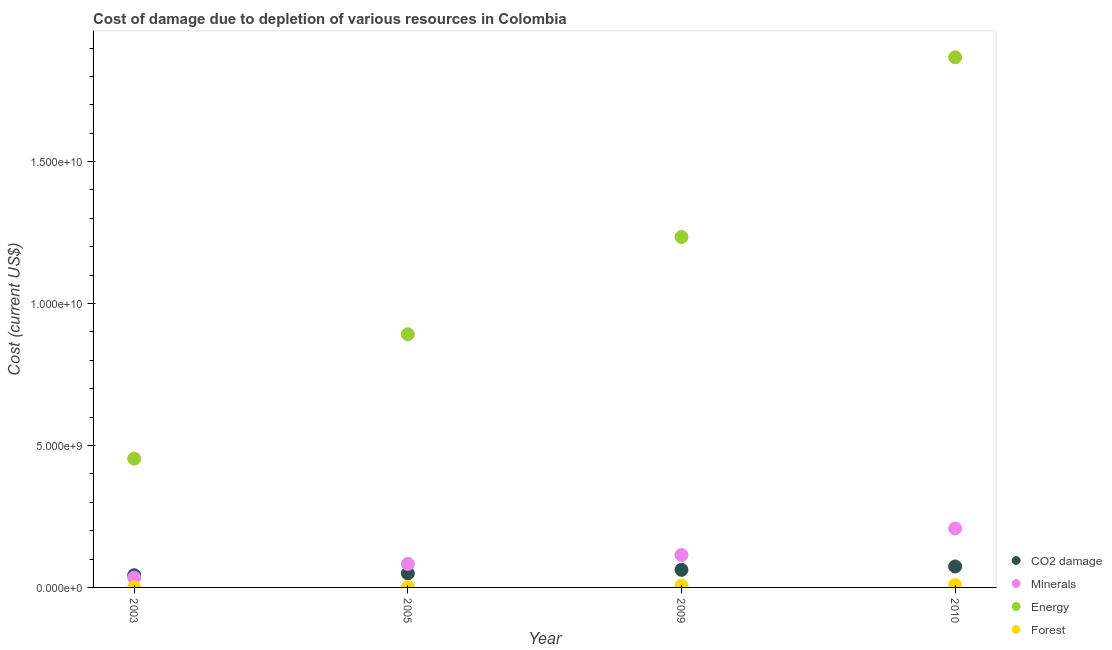Is the number of dotlines equal to the number of legend labels?
Make the answer very short. Yes. What is the cost of damage due to depletion of minerals in 2010?
Make the answer very short. 2.08e+09. Across all years, what is the maximum cost of damage due to depletion of minerals?
Your answer should be compact. 2.08e+09. Across all years, what is the minimum cost of damage due to depletion of forests?
Make the answer very short. 7.93e+06. In which year was the cost of damage due to depletion of coal maximum?
Keep it short and to the point. 2010. What is the total cost of damage due to depletion of forests in the graph?
Ensure brevity in your answer.  1.58e+08. What is the difference between the cost of damage due to depletion of coal in 2005 and that in 2010?
Provide a short and direct response. -2.45e+08. What is the difference between the cost of damage due to depletion of coal in 2003 and the cost of damage due to depletion of minerals in 2009?
Provide a short and direct response. -7.13e+08. What is the average cost of damage due to depletion of forests per year?
Provide a short and direct response. 3.96e+07. In the year 2005, what is the difference between the cost of damage due to depletion of coal and cost of damage due to depletion of minerals?
Your answer should be very brief. -3.33e+08. In how many years, is the cost of damage due to depletion of energy greater than 8000000000 US$?
Make the answer very short. 3. What is the ratio of the cost of damage due to depletion of forests in 2005 to that in 2009?
Ensure brevity in your answer.  0.13. Is the cost of damage due to depletion of minerals in 2003 less than that in 2005?
Keep it short and to the point. Yes. Is the difference between the cost of damage due to depletion of coal in 2003 and 2005 greater than the difference between the cost of damage due to depletion of minerals in 2003 and 2005?
Your answer should be compact. Yes. What is the difference between the highest and the second highest cost of damage due to depletion of coal?
Your answer should be compact. 1.19e+08. What is the difference between the highest and the lowest cost of damage due to depletion of forests?
Your answer should be very brief. 7.32e+07. Is the sum of the cost of damage due to depletion of forests in 2003 and 2005 greater than the maximum cost of damage due to depletion of minerals across all years?
Your answer should be very brief. No. Does the cost of damage due to depletion of minerals monotonically increase over the years?
Your answer should be compact. Yes. Is the cost of damage due to depletion of minerals strictly less than the cost of damage due to depletion of forests over the years?
Make the answer very short. No. How many years are there in the graph?
Provide a succinct answer. 4. What is the difference between two consecutive major ticks on the Y-axis?
Offer a terse response. 5.00e+09. Are the values on the major ticks of Y-axis written in scientific E-notation?
Ensure brevity in your answer.  Yes. Does the graph contain any zero values?
Provide a short and direct response. No. Does the graph contain grids?
Offer a very short reply. No. How many legend labels are there?
Give a very brief answer. 4. How are the legend labels stacked?
Your answer should be compact. Vertical. What is the title of the graph?
Make the answer very short. Cost of damage due to depletion of various resources in Colombia . What is the label or title of the X-axis?
Ensure brevity in your answer.  Year. What is the label or title of the Y-axis?
Your answer should be compact. Cost (current US$). What is the Cost (current US$) of CO2 damage in 2003?
Your answer should be very brief. 4.29e+08. What is the Cost (current US$) of Minerals in 2003?
Your response must be concise. 3.44e+08. What is the Cost (current US$) in Energy in 2003?
Provide a succinct answer. 4.54e+09. What is the Cost (current US$) of Forest in 2003?
Ensure brevity in your answer.  9.33e+06. What is the Cost (current US$) of CO2 damage in 2005?
Your answer should be very brief. 4.94e+08. What is the Cost (current US$) in Minerals in 2005?
Your answer should be compact. 8.27e+08. What is the Cost (current US$) of Energy in 2005?
Your answer should be compact. 8.92e+09. What is the Cost (current US$) of Forest in 2005?
Offer a very short reply. 7.93e+06. What is the Cost (current US$) in CO2 damage in 2009?
Offer a terse response. 6.20e+08. What is the Cost (current US$) of Minerals in 2009?
Provide a short and direct response. 1.14e+09. What is the Cost (current US$) in Energy in 2009?
Your answer should be compact. 1.23e+1. What is the Cost (current US$) of Forest in 2009?
Keep it short and to the point. 5.99e+07. What is the Cost (current US$) in CO2 damage in 2010?
Provide a succinct answer. 7.39e+08. What is the Cost (current US$) of Minerals in 2010?
Your answer should be compact. 2.08e+09. What is the Cost (current US$) in Energy in 2010?
Keep it short and to the point. 1.87e+1. What is the Cost (current US$) in Forest in 2010?
Your response must be concise. 8.12e+07. Across all years, what is the maximum Cost (current US$) of CO2 damage?
Your answer should be compact. 7.39e+08. Across all years, what is the maximum Cost (current US$) of Minerals?
Provide a succinct answer. 2.08e+09. Across all years, what is the maximum Cost (current US$) of Energy?
Provide a succinct answer. 1.87e+1. Across all years, what is the maximum Cost (current US$) of Forest?
Offer a very short reply. 8.12e+07. Across all years, what is the minimum Cost (current US$) of CO2 damage?
Your response must be concise. 4.29e+08. Across all years, what is the minimum Cost (current US$) of Minerals?
Provide a short and direct response. 3.44e+08. Across all years, what is the minimum Cost (current US$) of Energy?
Your answer should be very brief. 4.54e+09. Across all years, what is the minimum Cost (current US$) in Forest?
Your answer should be very brief. 7.93e+06. What is the total Cost (current US$) of CO2 damage in the graph?
Your answer should be very brief. 2.28e+09. What is the total Cost (current US$) in Minerals in the graph?
Make the answer very short. 4.39e+09. What is the total Cost (current US$) in Energy in the graph?
Provide a short and direct response. 4.45e+1. What is the total Cost (current US$) in Forest in the graph?
Your response must be concise. 1.58e+08. What is the difference between the Cost (current US$) of CO2 damage in 2003 and that in 2005?
Offer a terse response. -6.50e+07. What is the difference between the Cost (current US$) of Minerals in 2003 and that in 2005?
Offer a terse response. -4.83e+08. What is the difference between the Cost (current US$) of Energy in 2003 and that in 2005?
Keep it short and to the point. -4.38e+09. What is the difference between the Cost (current US$) of Forest in 2003 and that in 2005?
Your answer should be compact. 1.39e+06. What is the difference between the Cost (current US$) of CO2 damage in 2003 and that in 2009?
Your answer should be very brief. -1.91e+08. What is the difference between the Cost (current US$) of Minerals in 2003 and that in 2009?
Keep it short and to the point. -7.99e+08. What is the difference between the Cost (current US$) of Energy in 2003 and that in 2009?
Keep it short and to the point. -7.81e+09. What is the difference between the Cost (current US$) of Forest in 2003 and that in 2009?
Offer a terse response. -5.06e+07. What is the difference between the Cost (current US$) of CO2 damage in 2003 and that in 2010?
Your response must be concise. -3.10e+08. What is the difference between the Cost (current US$) of Minerals in 2003 and that in 2010?
Offer a very short reply. -1.73e+09. What is the difference between the Cost (current US$) of Energy in 2003 and that in 2010?
Ensure brevity in your answer.  -1.41e+1. What is the difference between the Cost (current US$) of Forest in 2003 and that in 2010?
Offer a terse response. -7.18e+07. What is the difference between the Cost (current US$) of CO2 damage in 2005 and that in 2009?
Ensure brevity in your answer.  -1.26e+08. What is the difference between the Cost (current US$) of Minerals in 2005 and that in 2009?
Give a very brief answer. -3.15e+08. What is the difference between the Cost (current US$) in Energy in 2005 and that in 2009?
Offer a very short reply. -3.43e+09. What is the difference between the Cost (current US$) of Forest in 2005 and that in 2009?
Provide a succinct answer. -5.20e+07. What is the difference between the Cost (current US$) of CO2 damage in 2005 and that in 2010?
Give a very brief answer. -2.45e+08. What is the difference between the Cost (current US$) of Minerals in 2005 and that in 2010?
Offer a very short reply. -1.25e+09. What is the difference between the Cost (current US$) of Energy in 2005 and that in 2010?
Offer a terse response. -9.76e+09. What is the difference between the Cost (current US$) of Forest in 2005 and that in 2010?
Offer a terse response. -7.32e+07. What is the difference between the Cost (current US$) of CO2 damage in 2009 and that in 2010?
Offer a very short reply. -1.19e+08. What is the difference between the Cost (current US$) of Minerals in 2009 and that in 2010?
Your answer should be very brief. -9.35e+08. What is the difference between the Cost (current US$) of Energy in 2009 and that in 2010?
Provide a short and direct response. -6.33e+09. What is the difference between the Cost (current US$) in Forest in 2009 and that in 2010?
Your answer should be very brief. -2.12e+07. What is the difference between the Cost (current US$) in CO2 damage in 2003 and the Cost (current US$) in Minerals in 2005?
Provide a succinct answer. -3.98e+08. What is the difference between the Cost (current US$) of CO2 damage in 2003 and the Cost (current US$) of Energy in 2005?
Offer a very short reply. -8.49e+09. What is the difference between the Cost (current US$) of CO2 damage in 2003 and the Cost (current US$) of Forest in 2005?
Your response must be concise. 4.21e+08. What is the difference between the Cost (current US$) of Minerals in 2003 and the Cost (current US$) of Energy in 2005?
Give a very brief answer. -8.57e+09. What is the difference between the Cost (current US$) in Minerals in 2003 and the Cost (current US$) in Forest in 2005?
Give a very brief answer. 3.36e+08. What is the difference between the Cost (current US$) of Energy in 2003 and the Cost (current US$) of Forest in 2005?
Your response must be concise. 4.53e+09. What is the difference between the Cost (current US$) in CO2 damage in 2003 and the Cost (current US$) in Minerals in 2009?
Provide a succinct answer. -7.13e+08. What is the difference between the Cost (current US$) of CO2 damage in 2003 and the Cost (current US$) of Energy in 2009?
Make the answer very short. -1.19e+1. What is the difference between the Cost (current US$) in CO2 damage in 2003 and the Cost (current US$) in Forest in 2009?
Your answer should be very brief. 3.69e+08. What is the difference between the Cost (current US$) of Minerals in 2003 and the Cost (current US$) of Energy in 2009?
Your answer should be very brief. -1.20e+1. What is the difference between the Cost (current US$) in Minerals in 2003 and the Cost (current US$) in Forest in 2009?
Provide a short and direct response. 2.84e+08. What is the difference between the Cost (current US$) in Energy in 2003 and the Cost (current US$) in Forest in 2009?
Provide a succinct answer. 4.48e+09. What is the difference between the Cost (current US$) in CO2 damage in 2003 and the Cost (current US$) in Minerals in 2010?
Your response must be concise. -1.65e+09. What is the difference between the Cost (current US$) in CO2 damage in 2003 and the Cost (current US$) in Energy in 2010?
Your response must be concise. -1.82e+1. What is the difference between the Cost (current US$) of CO2 damage in 2003 and the Cost (current US$) of Forest in 2010?
Offer a terse response. 3.48e+08. What is the difference between the Cost (current US$) in Minerals in 2003 and the Cost (current US$) in Energy in 2010?
Give a very brief answer. -1.83e+1. What is the difference between the Cost (current US$) of Minerals in 2003 and the Cost (current US$) of Forest in 2010?
Make the answer very short. 2.63e+08. What is the difference between the Cost (current US$) of Energy in 2003 and the Cost (current US$) of Forest in 2010?
Ensure brevity in your answer.  4.46e+09. What is the difference between the Cost (current US$) in CO2 damage in 2005 and the Cost (current US$) in Minerals in 2009?
Your answer should be compact. -6.48e+08. What is the difference between the Cost (current US$) of CO2 damage in 2005 and the Cost (current US$) of Energy in 2009?
Give a very brief answer. -1.19e+1. What is the difference between the Cost (current US$) in CO2 damage in 2005 and the Cost (current US$) in Forest in 2009?
Ensure brevity in your answer.  4.34e+08. What is the difference between the Cost (current US$) in Minerals in 2005 and the Cost (current US$) in Energy in 2009?
Give a very brief answer. -1.15e+1. What is the difference between the Cost (current US$) in Minerals in 2005 and the Cost (current US$) in Forest in 2009?
Provide a succinct answer. 7.67e+08. What is the difference between the Cost (current US$) in Energy in 2005 and the Cost (current US$) in Forest in 2009?
Offer a very short reply. 8.86e+09. What is the difference between the Cost (current US$) in CO2 damage in 2005 and the Cost (current US$) in Minerals in 2010?
Your answer should be compact. -1.58e+09. What is the difference between the Cost (current US$) of CO2 damage in 2005 and the Cost (current US$) of Energy in 2010?
Your response must be concise. -1.82e+1. What is the difference between the Cost (current US$) of CO2 damage in 2005 and the Cost (current US$) of Forest in 2010?
Keep it short and to the point. 4.13e+08. What is the difference between the Cost (current US$) in Minerals in 2005 and the Cost (current US$) in Energy in 2010?
Your answer should be compact. -1.78e+1. What is the difference between the Cost (current US$) in Minerals in 2005 and the Cost (current US$) in Forest in 2010?
Ensure brevity in your answer.  7.46e+08. What is the difference between the Cost (current US$) of Energy in 2005 and the Cost (current US$) of Forest in 2010?
Keep it short and to the point. 8.84e+09. What is the difference between the Cost (current US$) of CO2 damage in 2009 and the Cost (current US$) of Minerals in 2010?
Provide a short and direct response. -1.46e+09. What is the difference between the Cost (current US$) of CO2 damage in 2009 and the Cost (current US$) of Energy in 2010?
Your answer should be compact. -1.81e+1. What is the difference between the Cost (current US$) of CO2 damage in 2009 and the Cost (current US$) of Forest in 2010?
Offer a very short reply. 5.38e+08. What is the difference between the Cost (current US$) of Minerals in 2009 and the Cost (current US$) of Energy in 2010?
Offer a terse response. -1.75e+1. What is the difference between the Cost (current US$) in Minerals in 2009 and the Cost (current US$) in Forest in 2010?
Provide a succinct answer. 1.06e+09. What is the difference between the Cost (current US$) in Energy in 2009 and the Cost (current US$) in Forest in 2010?
Your answer should be very brief. 1.23e+1. What is the average Cost (current US$) of CO2 damage per year?
Your answer should be compact. 5.70e+08. What is the average Cost (current US$) in Minerals per year?
Ensure brevity in your answer.  1.10e+09. What is the average Cost (current US$) of Energy per year?
Make the answer very short. 1.11e+1. What is the average Cost (current US$) of Forest per year?
Ensure brevity in your answer.  3.96e+07. In the year 2003, what is the difference between the Cost (current US$) in CO2 damage and Cost (current US$) in Minerals?
Offer a terse response. 8.51e+07. In the year 2003, what is the difference between the Cost (current US$) in CO2 damage and Cost (current US$) in Energy?
Give a very brief answer. -4.11e+09. In the year 2003, what is the difference between the Cost (current US$) of CO2 damage and Cost (current US$) of Forest?
Your answer should be very brief. 4.20e+08. In the year 2003, what is the difference between the Cost (current US$) in Minerals and Cost (current US$) in Energy?
Give a very brief answer. -4.19e+09. In the year 2003, what is the difference between the Cost (current US$) of Minerals and Cost (current US$) of Forest?
Provide a short and direct response. 3.35e+08. In the year 2003, what is the difference between the Cost (current US$) in Energy and Cost (current US$) in Forest?
Your answer should be very brief. 4.53e+09. In the year 2005, what is the difference between the Cost (current US$) in CO2 damage and Cost (current US$) in Minerals?
Ensure brevity in your answer.  -3.33e+08. In the year 2005, what is the difference between the Cost (current US$) of CO2 damage and Cost (current US$) of Energy?
Provide a succinct answer. -8.42e+09. In the year 2005, what is the difference between the Cost (current US$) of CO2 damage and Cost (current US$) of Forest?
Make the answer very short. 4.86e+08. In the year 2005, what is the difference between the Cost (current US$) in Minerals and Cost (current US$) in Energy?
Keep it short and to the point. -8.09e+09. In the year 2005, what is the difference between the Cost (current US$) in Minerals and Cost (current US$) in Forest?
Ensure brevity in your answer.  8.19e+08. In the year 2005, what is the difference between the Cost (current US$) in Energy and Cost (current US$) in Forest?
Make the answer very short. 8.91e+09. In the year 2009, what is the difference between the Cost (current US$) of CO2 damage and Cost (current US$) of Minerals?
Make the answer very short. -5.23e+08. In the year 2009, what is the difference between the Cost (current US$) of CO2 damage and Cost (current US$) of Energy?
Provide a short and direct response. -1.17e+1. In the year 2009, what is the difference between the Cost (current US$) in CO2 damage and Cost (current US$) in Forest?
Offer a very short reply. 5.60e+08. In the year 2009, what is the difference between the Cost (current US$) in Minerals and Cost (current US$) in Energy?
Give a very brief answer. -1.12e+1. In the year 2009, what is the difference between the Cost (current US$) in Minerals and Cost (current US$) in Forest?
Your response must be concise. 1.08e+09. In the year 2009, what is the difference between the Cost (current US$) in Energy and Cost (current US$) in Forest?
Offer a very short reply. 1.23e+1. In the year 2010, what is the difference between the Cost (current US$) in CO2 damage and Cost (current US$) in Minerals?
Provide a succinct answer. -1.34e+09. In the year 2010, what is the difference between the Cost (current US$) in CO2 damage and Cost (current US$) in Energy?
Offer a terse response. -1.79e+1. In the year 2010, what is the difference between the Cost (current US$) in CO2 damage and Cost (current US$) in Forest?
Keep it short and to the point. 6.57e+08. In the year 2010, what is the difference between the Cost (current US$) in Minerals and Cost (current US$) in Energy?
Offer a terse response. -1.66e+1. In the year 2010, what is the difference between the Cost (current US$) of Minerals and Cost (current US$) of Forest?
Your answer should be very brief. 2.00e+09. In the year 2010, what is the difference between the Cost (current US$) of Energy and Cost (current US$) of Forest?
Give a very brief answer. 1.86e+1. What is the ratio of the Cost (current US$) in CO2 damage in 2003 to that in 2005?
Give a very brief answer. 0.87. What is the ratio of the Cost (current US$) in Minerals in 2003 to that in 2005?
Offer a terse response. 0.42. What is the ratio of the Cost (current US$) of Energy in 2003 to that in 2005?
Provide a short and direct response. 0.51. What is the ratio of the Cost (current US$) in Forest in 2003 to that in 2005?
Your response must be concise. 1.18. What is the ratio of the Cost (current US$) of CO2 damage in 2003 to that in 2009?
Offer a terse response. 0.69. What is the ratio of the Cost (current US$) of Minerals in 2003 to that in 2009?
Your response must be concise. 0.3. What is the ratio of the Cost (current US$) in Energy in 2003 to that in 2009?
Offer a terse response. 0.37. What is the ratio of the Cost (current US$) of Forest in 2003 to that in 2009?
Offer a terse response. 0.16. What is the ratio of the Cost (current US$) of CO2 damage in 2003 to that in 2010?
Provide a short and direct response. 0.58. What is the ratio of the Cost (current US$) of Minerals in 2003 to that in 2010?
Your answer should be very brief. 0.17. What is the ratio of the Cost (current US$) in Energy in 2003 to that in 2010?
Your response must be concise. 0.24. What is the ratio of the Cost (current US$) in Forest in 2003 to that in 2010?
Offer a very short reply. 0.11. What is the ratio of the Cost (current US$) of CO2 damage in 2005 to that in 2009?
Make the answer very short. 0.8. What is the ratio of the Cost (current US$) of Minerals in 2005 to that in 2009?
Ensure brevity in your answer.  0.72. What is the ratio of the Cost (current US$) in Energy in 2005 to that in 2009?
Make the answer very short. 0.72. What is the ratio of the Cost (current US$) in Forest in 2005 to that in 2009?
Keep it short and to the point. 0.13. What is the ratio of the Cost (current US$) of CO2 damage in 2005 to that in 2010?
Your answer should be very brief. 0.67. What is the ratio of the Cost (current US$) in Minerals in 2005 to that in 2010?
Your answer should be compact. 0.4. What is the ratio of the Cost (current US$) in Energy in 2005 to that in 2010?
Keep it short and to the point. 0.48. What is the ratio of the Cost (current US$) in Forest in 2005 to that in 2010?
Offer a terse response. 0.1. What is the ratio of the Cost (current US$) in CO2 damage in 2009 to that in 2010?
Make the answer very short. 0.84. What is the ratio of the Cost (current US$) of Minerals in 2009 to that in 2010?
Provide a short and direct response. 0.55. What is the ratio of the Cost (current US$) in Energy in 2009 to that in 2010?
Your answer should be very brief. 0.66. What is the ratio of the Cost (current US$) of Forest in 2009 to that in 2010?
Keep it short and to the point. 0.74. What is the difference between the highest and the second highest Cost (current US$) of CO2 damage?
Ensure brevity in your answer.  1.19e+08. What is the difference between the highest and the second highest Cost (current US$) of Minerals?
Make the answer very short. 9.35e+08. What is the difference between the highest and the second highest Cost (current US$) in Energy?
Keep it short and to the point. 6.33e+09. What is the difference between the highest and the second highest Cost (current US$) in Forest?
Provide a succinct answer. 2.12e+07. What is the difference between the highest and the lowest Cost (current US$) of CO2 damage?
Your answer should be very brief. 3.10e+08. What is the difference between the highest and the lowest Cost (current US$) in Minerals?
Make the answer very short. 1.73e+09. What is the difference between the highest and the lowest Cost (current US$) in Energy?
Your answer should be compact. 1.41e+1. What is the difference between the highest and the lowest Cost (current US$) of Forest?
Provide a succinct answer. 7.32e+07. 